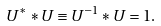Convert formula to latex. <formula><loc_0><loc_0><loc_500><loc_500>U ^ { * } * U \equiv U ^ { - 1 } * U = 1 .</formula> 